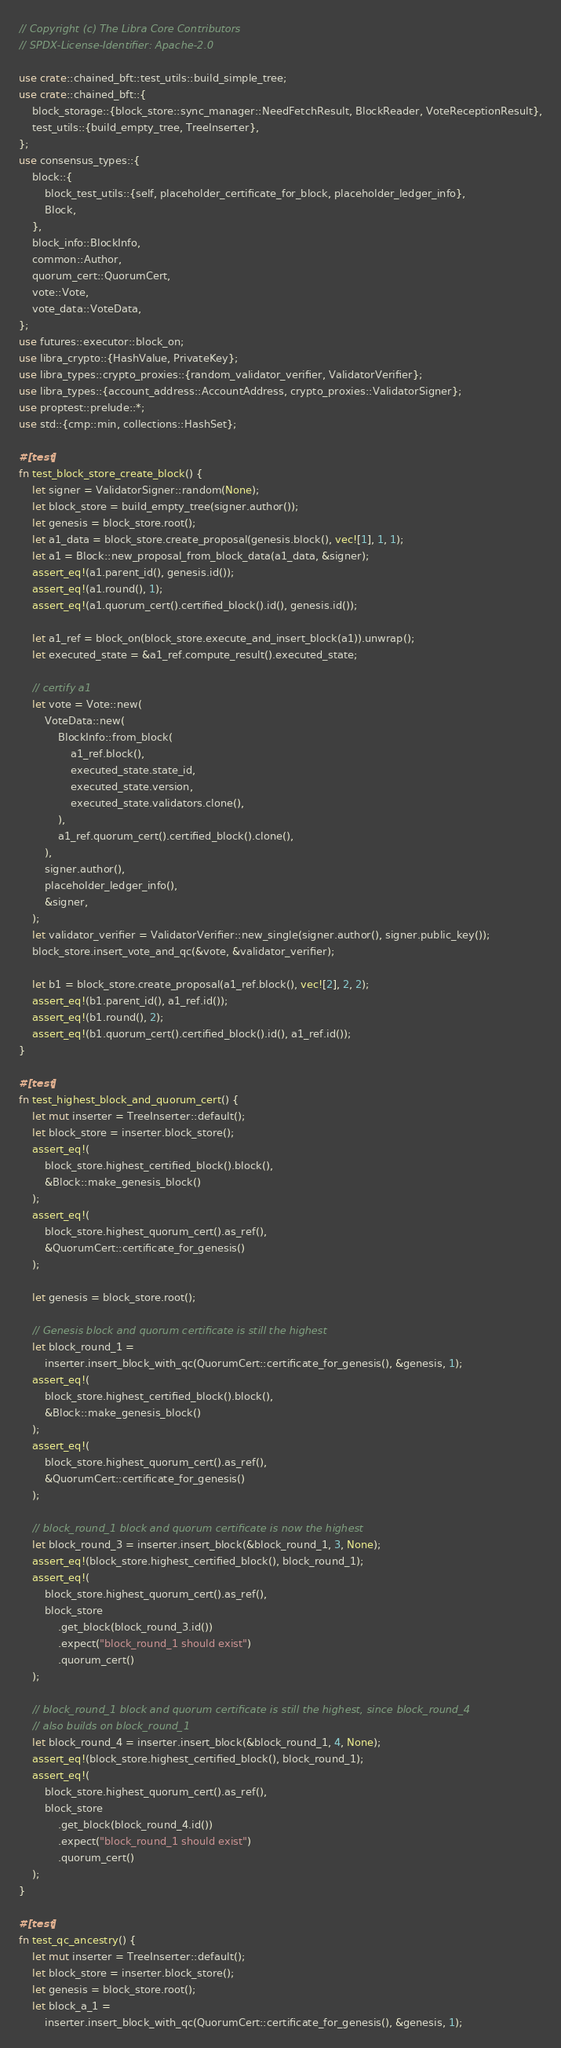Convert code to text. <code><loc_0><loc_0><loc_500><loc_500><_Rust_>// Copyright (c) The Libra Core Contributors
// SPDX-License-Identifier: Apache-2.0

use crate::chained_bft::test_utils::build_simple_tree;
use crate::chained_bft::{
    block_storage::{block_store::sync_manager::NeedFetchResult, BlockReader, VoteReceptionResult},
    test_utils::{build_empty_tree, TreeInserter},
};
use consensus_types::{
    block::{
        block_test_utils::{self, placeholder_certificate_for_block, placeholder_ledger_info},
        Block,
    },
    block_info::BlockInfo,
    common::Author,
    quorum_cert::QuorumCert,
    vote::Vote,
    vote_data::VoteData,
};
use futures::executor::block_on;
use libra_crypto::{HashValue, PrivateKey};
use libra_types::crypto_proxies::{random_validator_verifier, ValidatorVerifier};
use libra_types::{account_address::AccountAddress, crypto_proxies::ValidatorSigner};
use proptest::prelude::*;
use std::{cmp::min, collections::HashSet};

#[test]
fn test_block_store_create_block() {
    let signer = ValidatorSigner::random(None);
    let block_store = build_empty_tree(signer.author());
    let genesis = block_store.root();
    let a1_data = block_store.create_proposal(genesis.block(), vec![1], 1, 1);
    let a1 = Block::new_proposal_from_block_data(a1_data, &signer);
    assert_eq!(a1.parent_id(), genesis.id());
    assert_eq!(a1.round(), 1);
    assert_eq!(a1.quorum_cert().certified_block().id(), genesis.id());

    let a1_ref = block_on(block_store.execute_and_insert_block(a1)).unwrap();
    let executed_state = &a1_ref.compute_result().executed_state;

    // certify a1
    let vote = Vote::new(
        VoteData::new(
            BlockInfo::from_block(
                a1_ref.block(),
                executed_state.state_id,
                executed_state.version,
                executed_state.validators.clone(),
            ),
            a1_ref.quorum_cert().certified_block().clone(),
        ),
        signer.author(),
        placeholder_ledger_info(),
        &signer,
    );
    let validator_verifier = ValidatorVerifier::new_single(signer.author(), signer.public_key());
    block_store.insert_vote_and_qc(&vote, &validator_verifier);

    let b1 = block_store.create_proposal(a1_ref.block(), vec![2], 2, 2);
    assert_eq!(b1.parent_id(), a1_ref.id());
    assert_eq!(b1.round(), 2);
    assert_eq!(b1.quorum_cert().certified_block().id(), a1_ref.id());
}

#[test]
fn test_highest_block_and_quorum_cert() {
    let mut inserter = TreeInserter::default();
    let block_store = inserter.block_store();
    assert_eq!(
        block_store.highest_certified_block().block(),
        &Block::make_genesis_block()
    );
    assert_eq!(
        block_store.highest_quorum_cert().as_ref(),
        &QuorumCert::certificate_for_genesis()
    );

    let genesis = block_store.root();

    // Genesis block and quorum certificate is still the highest
    let block_round_1 =
        inserter.insert_block_with_qc(QuorumCert::certificate_for_genesis(), &genesis, 1);
    assert_eq!(
        block_store.highest_certified_block().block(),
        &Block::make_genesis_block()
    );
    assert_eq!(
        block_store.highest_quorum_cert().as_ref(),
        &QuorumCert::certificate_for_genesis()
    );

    // block_round_1 block and quorum certificate is now the highest
    let block_round_3 = inserter.insert_block(&block_round_1, 3, None);
    assert_eq!(block_store.highest_certified_block(), block_round_1);
    assert_eq!(
        block_store.highest_quorum_cert().as_ref(),
        block_store
            .get_block(block_round_3.id())
            .expect("block_round_1 should exist")
            .quorum_cert()
    );

    // block_round_1 block and quorum certificate is still the highest, since block_round_4
    // also builds on block_round_1
    let block_round_4 = inserter.insert_block(&block_round_1, 4, None);
    assert_eq!(block_store.highest_certified_block(), block_round_1);
    assert_eq!(
        block_store.highest_quorum_cert().as_ref(),
        block_store
            .get_block(block_round_4.id())
            .expect("block_round_1 should exist")
            .quorum_cert()
    );
}

#[test]
fn test_qc_ancestry() {
    let mut inserter = TreeInserter::default();
    let block_store = inserter.block_store();
    let genesis = block_store.root();
    let block_a_1 =
        inserter.insert_block_with_qc(QuorumCert::certificate_for_genesis(), &genesis, 1);</code> 